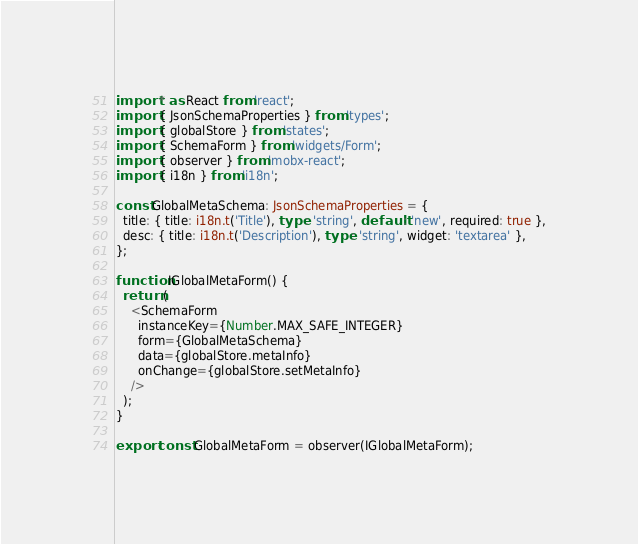<code> <loc_0><loc_0><loc_500><loc_500><_TypeScript_>import * as React from 'react';
import { JsonSchemaProperties } from 'types';
import { globalStore } from 'states';
import { SchemaForm } from 'widgets/Form';
import { observer } from 'mobx-react';
import { i18n } from 'i18n';

const GlobalMetaSchema: JsonSchemaProperties = {
  title: { title: i18n.t('Title'), type: 'string', default: 'new', required: true },
  desc: { title: i18n.t('Description'), type: 'string', widget: 'textarea' },
};

function IGlobalMetaForm() {
  return (
    <SchemaForm
      instanceKey={Number.MAX_SAFE_INTEGER}
      form={GlobalMetaSchema}
      data={globalStore.metaInfo}
      onChange={globalStore.setMetaInfo}
    />
  );
}

export const GlobalMetaForm = observer(IGlobalMetaForm);
</code> 